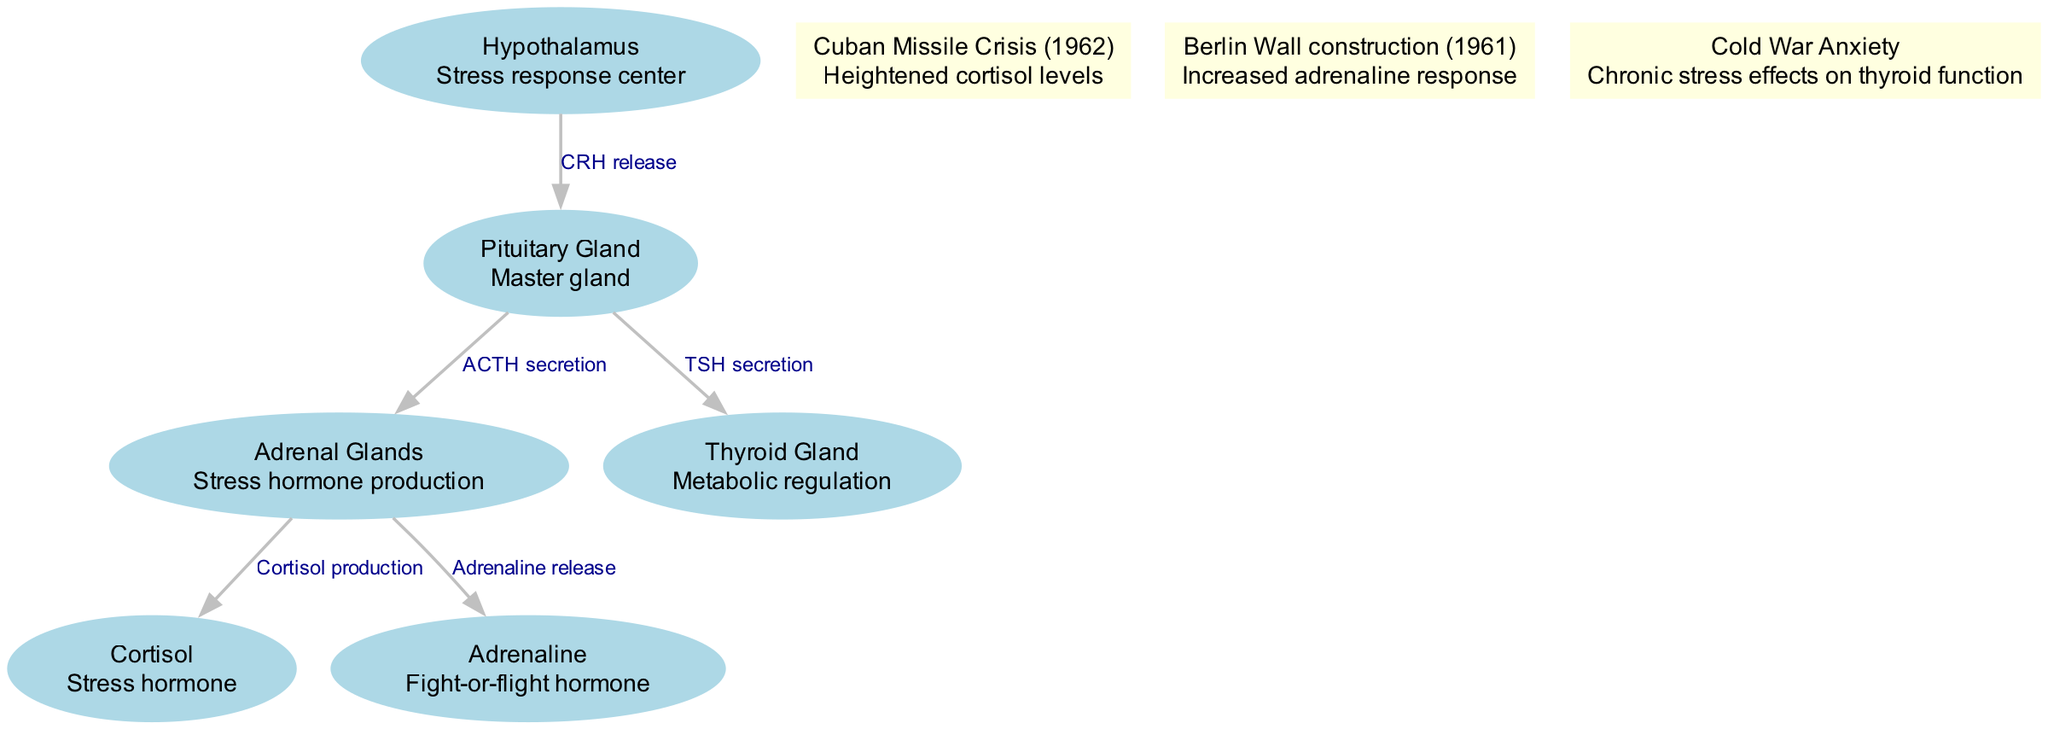What is the master gland in this diagram? The master gland listed in the diagram is the Pituitary Gland, which is responsible for regulating various hormonal functions in the endocrine system.
Answer: Pituitary Gland How many nodes are present in this diagram? The diagram contains six nodes: Hypothalamus, Pituitary Gland, Adrenal Glands, Thyroid Gland, Cortisol, and Adrenaline.
Answer: 6 Which hormone is released in response to the activation of the adrenal glands? The adrenal glands release two hormones: Cortisol and Adrenaline, both of which are linked to stress responses in the body.
Answer: Cortisol and Adrenaline What is the relationship between the hypothalamus and the pituitary gland? The relationship is characterized by the release of Corticotropin-Releasing Hormone (CRH) by the Hypothalamus, which stimulates the Pituitary Gland to secrete Adrenocorticotropic Hormone (ACTH).
Answer: CRH release During the Cuban Missile Crisis, what hormonal change is indicated in the diagram? The diagram indicates that cortisol levels heightened during the Cuban Missile Crisis, relating to increased stress responses at that time.
Answer: Heightened cortisol levels Which event is associated with an increased adrenaline response in the diagram? The Berlin Wall construction in 1961 is associated with an increased adrenaline response, illustrating how political events influence stress reactions.
Answer: Berlin Wall construction (1961) What does TSH secretion from the pituitary gland affect? TSH secretion from the Pituitary Gland affects the Thyroid Gland, promoting metabolic regulation and overall hormonal balance.
Answer: Thyroid Gland What chronic effect is noted in the diagram due to Cold War anxiety? The diagram notes that Cold War anxiety has chronic effects on thyroid function, highlighting the long-term implications of stress on health.
Answer: Chronic stress effects on thyroid function 